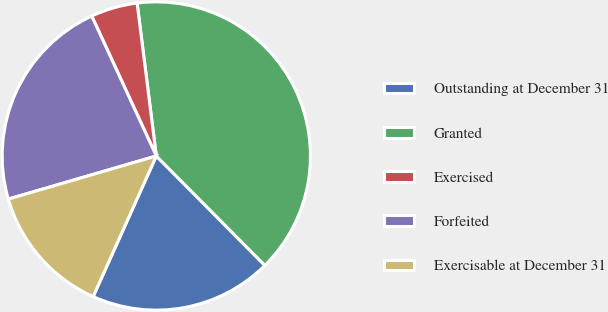<chart> <loc_0><loc_0><loc_500><loc_500><pie_chart><fcel>Outstanding at December 31<fcel>Granted<fcel>Exercised<fcel>Forfeited<fcel>Exercisable at December 31<nl><fcel>19.16%<fcel>39.55%<fcel>4.89%<fcel>22.63%<fcel>13.77%<nl></chart> 